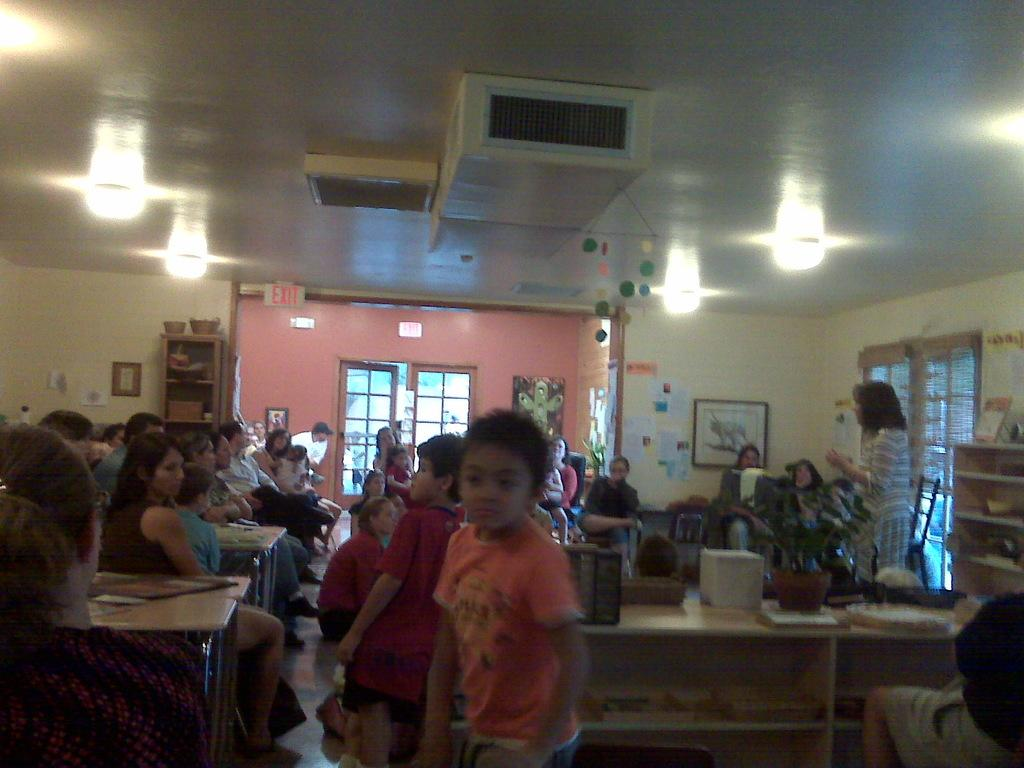What can be seen on the right side of the image? There are people on the right side of the image. What can be seen on the left side of the image? There are people on the left side of the image. What is located in the center of the image? There is a window in the center of the image. What is visible at the top side of the image? There are lights at the top side of the image. What type of orange is being served for lunch by the grandmother in the image? There is no grandmother, lunch, or orange present in the image. 